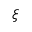<formula> <loc_0><loc_0><loc_500><loc_500>\xi</formula> 